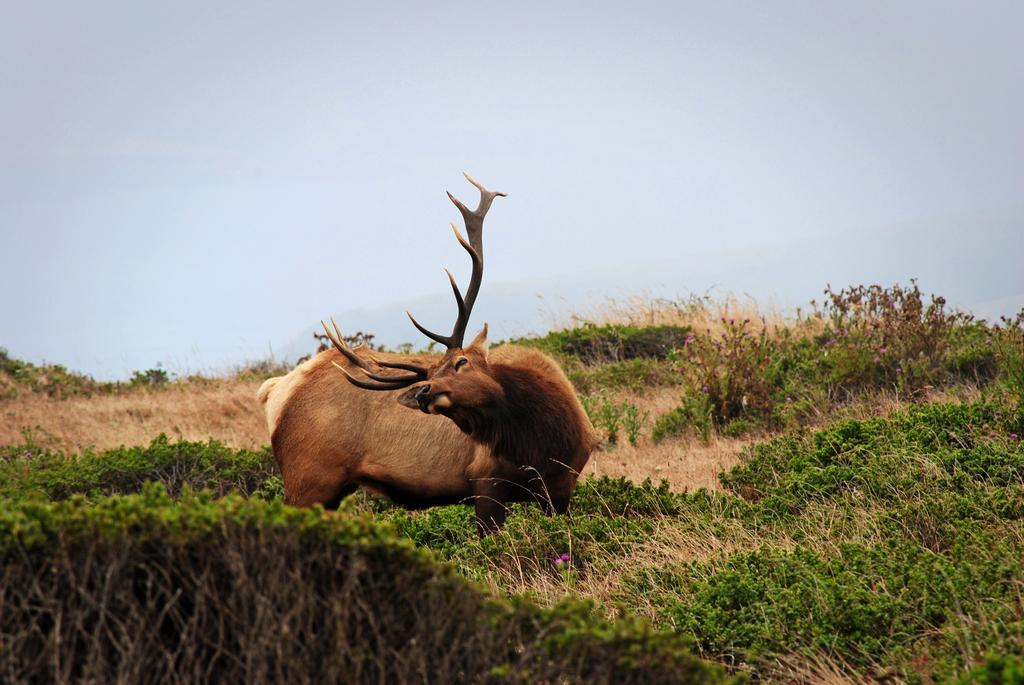Where was the image taken? The image was taken in a park. What is the main subject in the center of the image? There is an antelope in the center of the image. What can be seen in the foreground of the image? There are plants and dry grass in the foreground of the image. How would you describe the sky in the image? The sky is foggy in the image. What type of meat is the antelope holding in its mouth in the image? There is no meat present in the image, and the antelope is not holding anything in its mouth. 